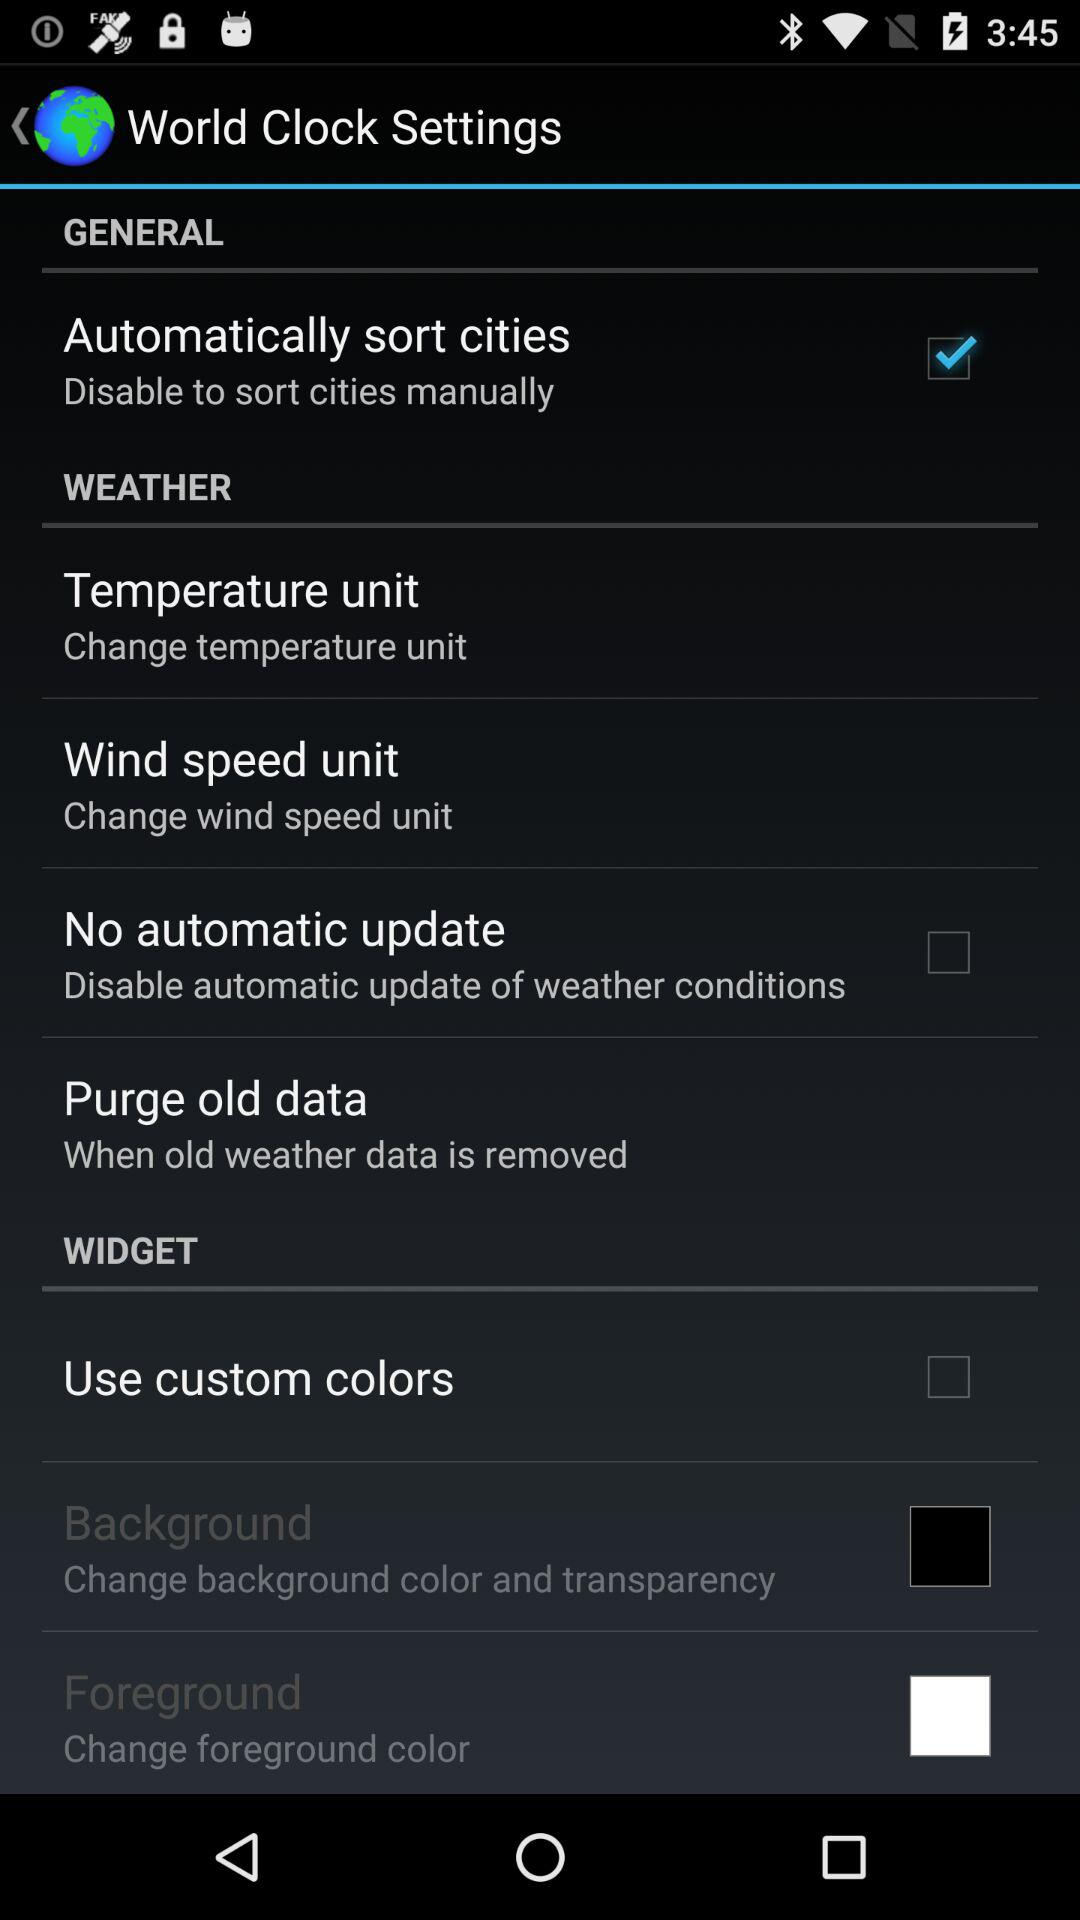What is the status of "Automatically sort cities"? The status is "on". 